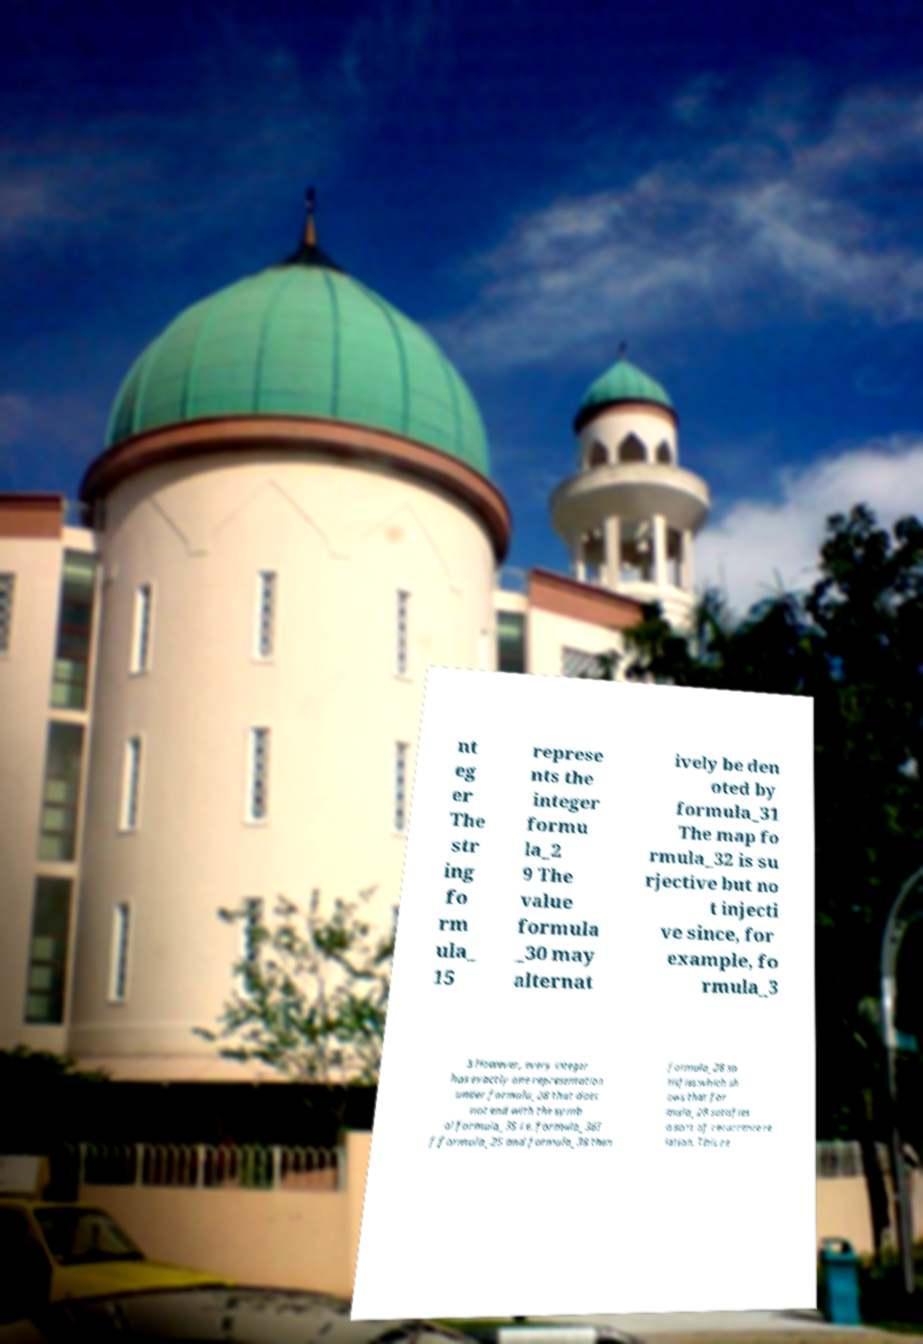Can you accurately transcribe the text from the provided image for me? nt eg er The str ing fo rm ula_ 15 represe nts the integer formu la_2 9 The value formula _30 may alternat ively be den oted by formula_31 The map fo rmula_32 is su rjective but no t injecti ve since, for example, fo rmula_3 3 However, every integer has exactly one representation under formula_28 that does not end with the symb ol formula_35 i.e. formula_36I f formula_25 and formula_38 then formula_28 sa tisfies:which sh ows that for mula_28 satisfies a sort of recurrence re lation. This re 